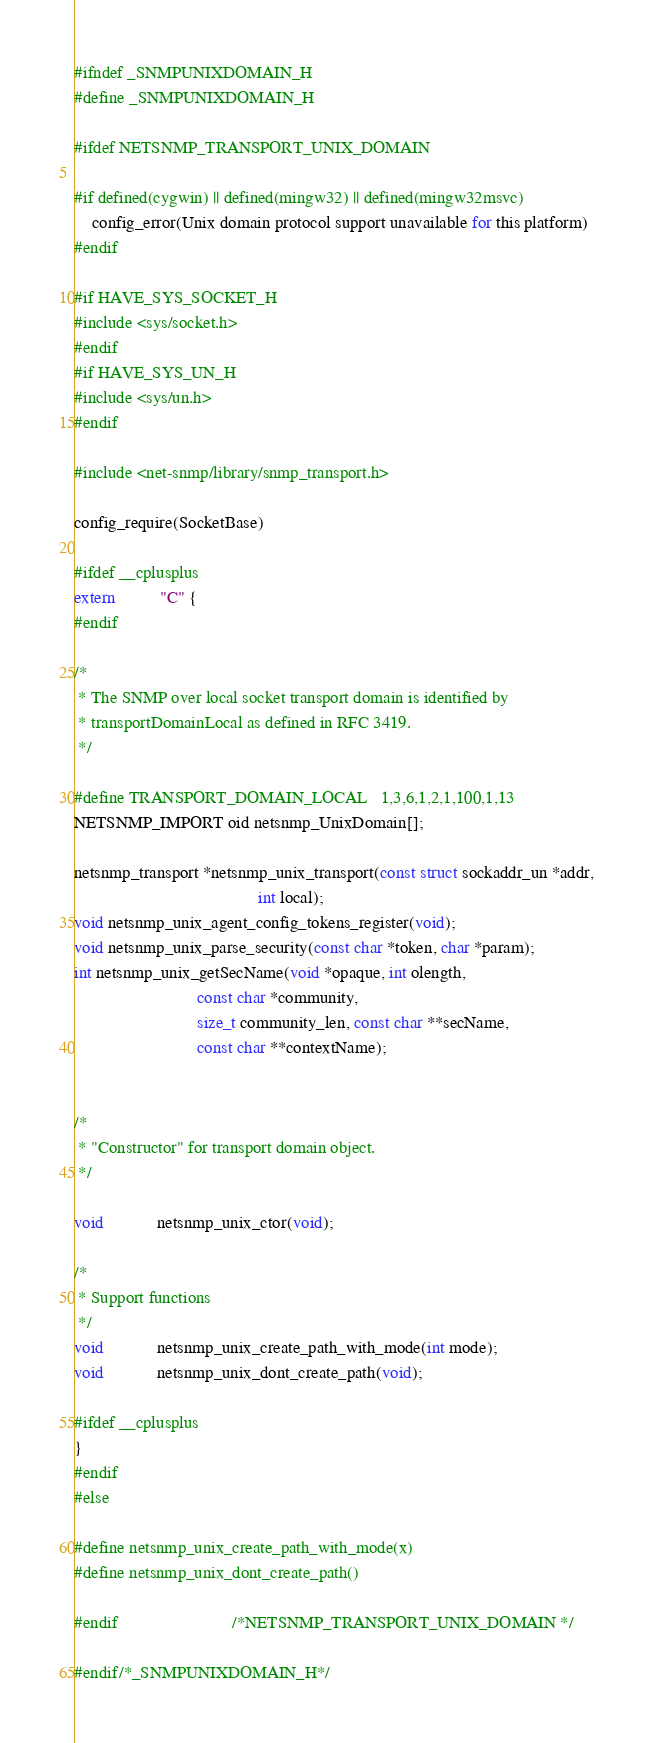<code> <loc_0><loc_0><loc_500><loc_500><_C_>#ifndef _SNMPUNIXDOMAIN_H
#define _SNMPUNIXDOMAIN_H

#ifdef NETSNMP_TRANSPORT_UNIX_DOMAIN

#if defined(cygwin) || defined(mingw32) || defined(mingw32msvc)
    config_error(Unix domain protocol support unavailable for this platform)
#endif

#if HAVE_SYS_SOCKET_H
#include <sys/socket.h>
#endif
#if HAVE_SYS_UN_H
#include <sys/un.h>
#endif

#include <net-snmp/library/snmp_transport.h>

config_require(SocketBase)

#ifdef __cplusplus
extern          "C" {
#endif

/*
 * The SNMP over local socket transport domain is identified by
 * transportDomainLocal as defined in RFC 3419.
 */

#define TRANSPORT_DOMAIN_LOCAL	1,3,6,1,2,1,100,1,13
NETSNMP_IMPORT oid netsnmp_UnixDomain[];

netsnmp_transport *netsnmp_unix_transport(const struct sockaddr_un *addr,
                                          int local);
void netsnmp_unix_agent_config_tokens_register(void);
void netsnmp_unix_parse_security(const char *token, char *param);
int netsnmp_unix_getSecName(void *opaque, int olength,
                            const char *community,
                            size_t community_len, const char **secName,
                            const char **contextName);


/*
 * "Constructor" for transport domain object.  
 */

void            netsnmp_unix_ctor(void);

/*
 * Support functions
 */
void            netsnmp_unix_create_path_with_mode(int mode);
void            netsnmp_unix_dont_create_path(void);

#ifdef __cplusplus
}
#endif
#else

#define netsnmp_unix_create_path_with_mode(x)
#define netsnmp_unix_dont_create_path()

#endif                          /*NETSNMP_TRANSPORT_UNIX_DOMAIN */

#endif/*_SNMPUNIXDOMAIN_H*/
</code> 